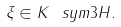<formula> <loc_0><loc_0><loc_500><loc_500>\xi \in K \ s y m 3 H .</formula> 